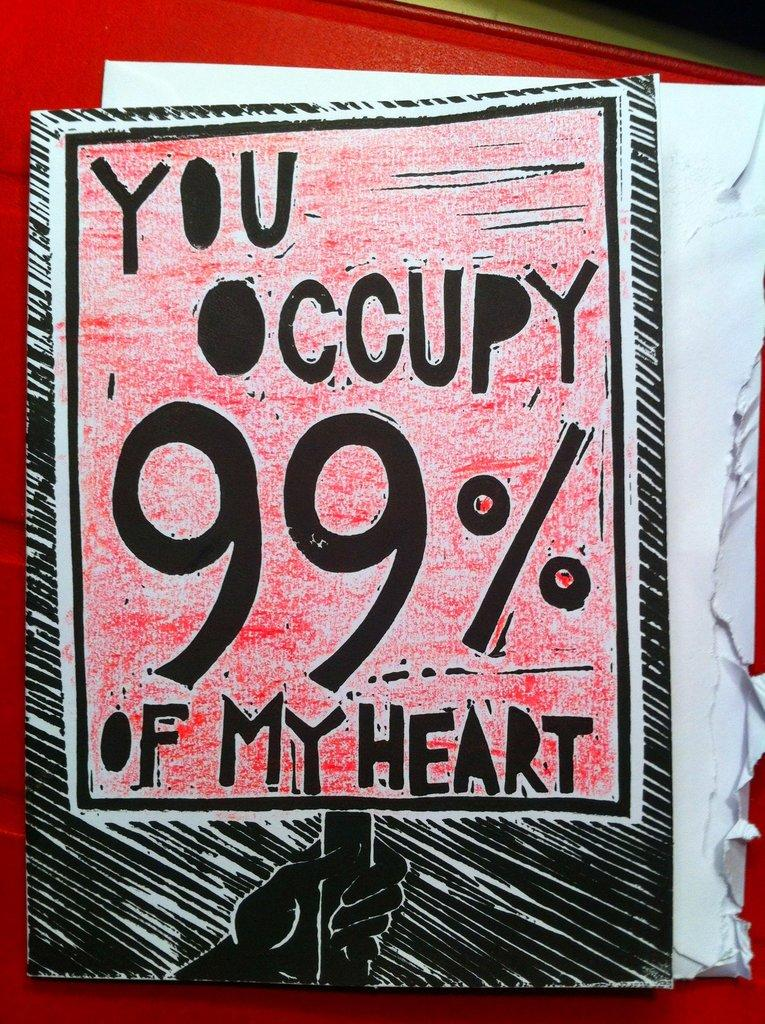<image>
Offer a succinct explanation of the picture presented. a paper that says 'you occupy 99% of my heart' on it 